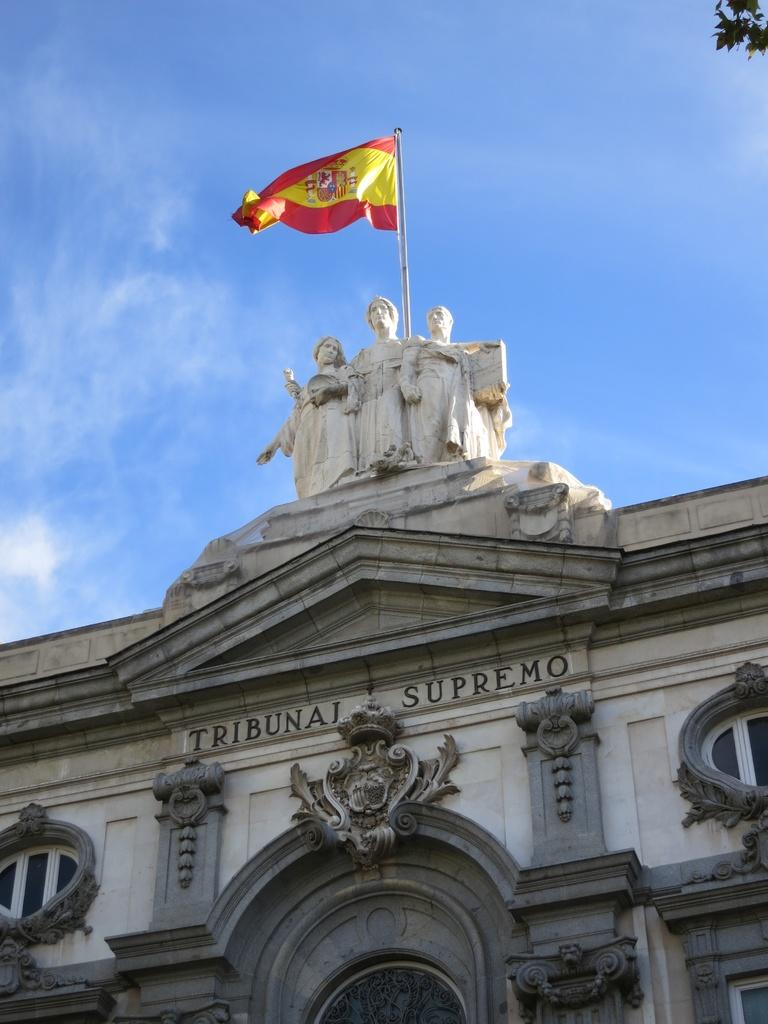What type of structure is present in the image? There is a building in the image. What feature can be seen on the building? The building has windows. What artistic elements are present in the image? There are sculptures in the image. What is used to display a flag in the image? There is a flagpole in the image. What type of natural elements can be seen in the image? There are leaves visible in the image. What is visible in the background of the image? The sky is visible in the image. What type of cracker is being used to propel the wheel in the image? There is no cracker or wheel present in the image. What type of shoes are the people wearing in the image? There are no people or shoes visible in the image. 